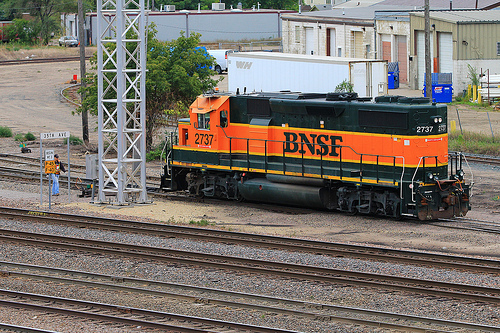What type of location is this train situated in? The train is located at what appears to be a train yard or a rail junction, as suggested by the multiple tracks and the industrial equipment in the background. 